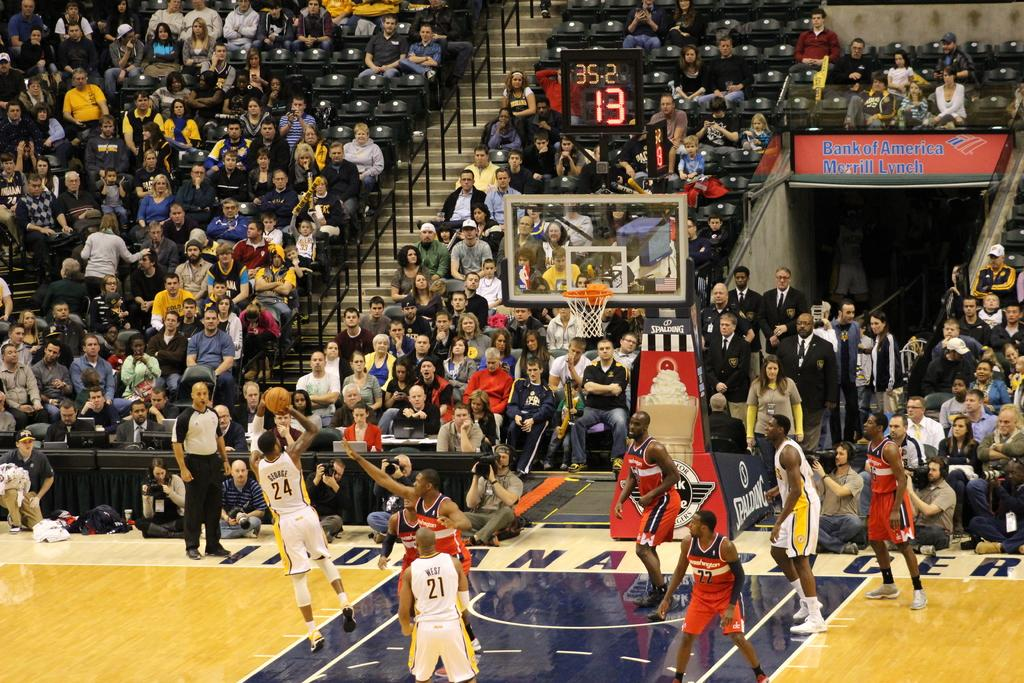<image>
Present a compact description of the photo's key features. A basketball game at the Indiana Pacer's court. 